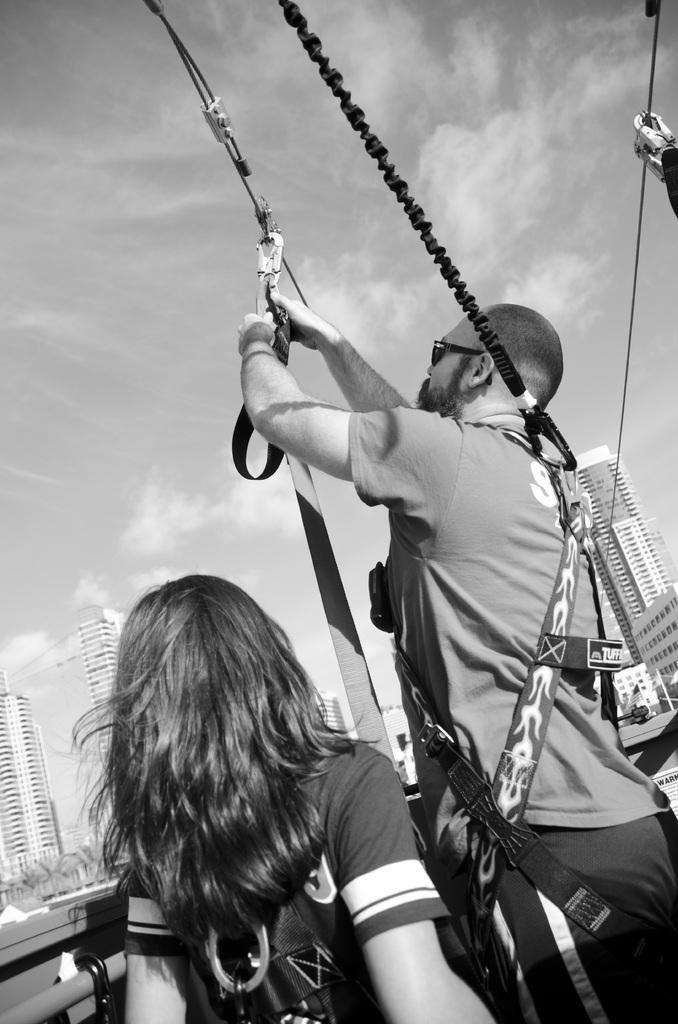Can you describe this image briefly? This is a black and white image. We can see there are two persons, ropes and a cable. On the left side of the woman there is an iron rod. On the left and right side of the image there are buildings. Behind the buildings there is the sky. 